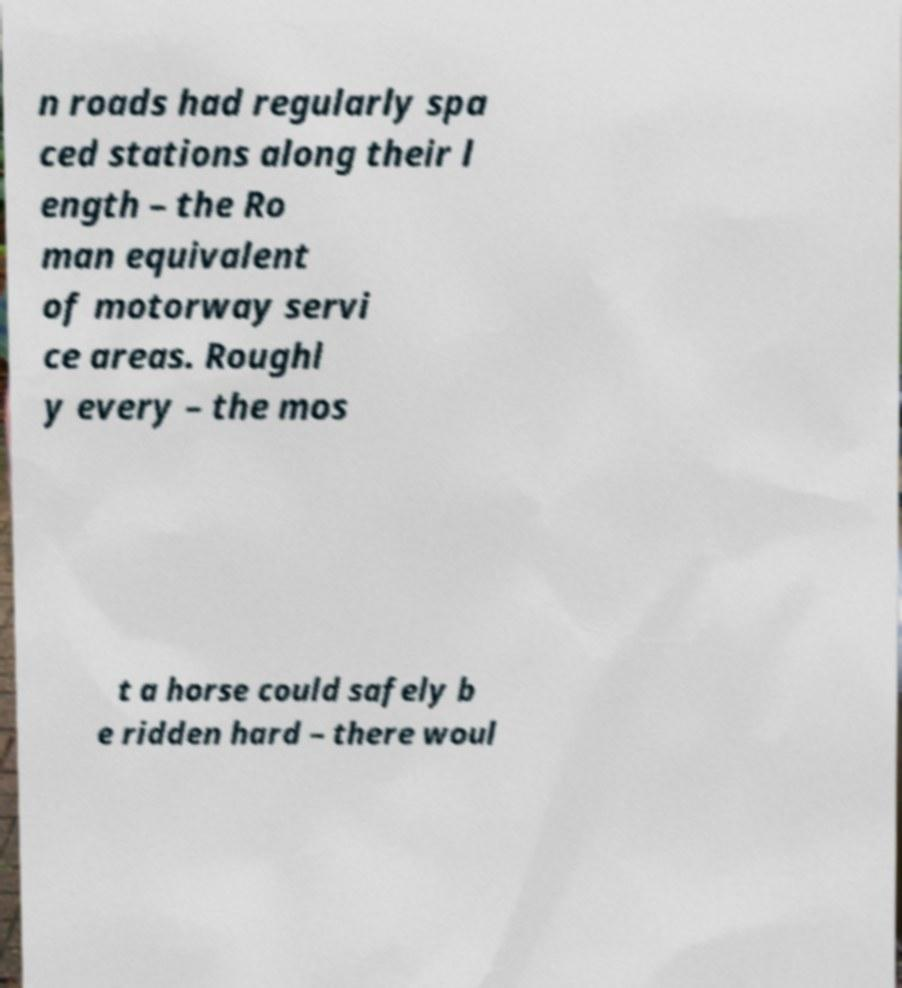For documentation purposes, I need the text within this image transcribed. Could you provide that? n roads had regularly spa ced stations along their l ength – the Ro man equivalent of motorway servi ce areas. Roughl y every – the mos t a horse could safely b e ridden hard – there woul 